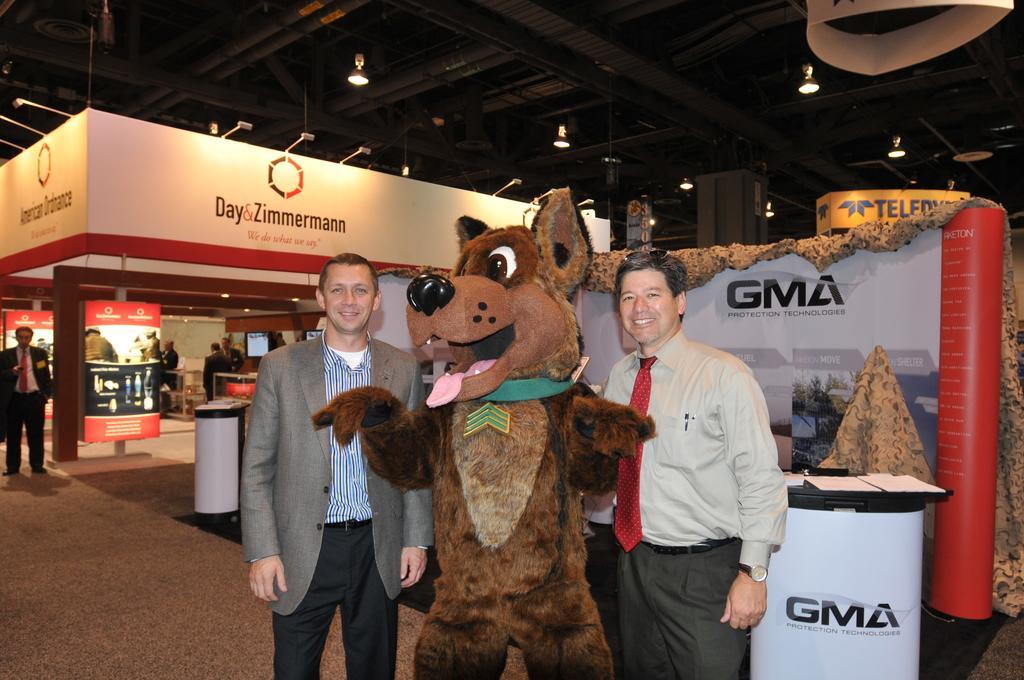Can you describe this image briefly? In this picture there are few persons standing and there is a toy in between them and there is a table behind them which has few papers on it and there are few banners and lights in the background and there are few persons standing in the left corner. 